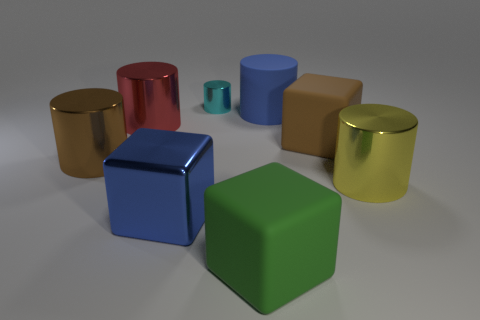What material is the big object that is the same color as the large rubber cylinder?
Ensure brevity in your answer.  Metal. Are there more large matte cubes than brown matte cubes?
Your answer should be very brief. Yes. There is a blue rubber object that is the same shape as the cyan object; what is its size?
Keep it short and to the point. Large. Are the big blue cube and the small cylinder behind the brown cylinder made of the same material?
Offer a terse response. Yes. How many things are large brown objects or matte objects?
Make the answer very short. 4. Do the cube that is left of the small object and the shiny object that is right of the small object have the same size?
Your response must be concise. Yes. How many cubes are metallic things or large blue things?
Offer a terse response. 1. Is there a large red cylinder?
Make the answer very short. Yes. Are there any other things that are the same shape as the big blue metal object?
Offer a terse response. Yes. Do the tiny metal object and the rubber cylinder have the same color?
Offer a very short reply. No. 